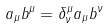<formula> <loc_0><loc_0><loc_500><loc_500>a _ { \mu } b ^ { \mu } = \delta ^ { \mu } _ { \nu } a _ { \mu } b ^ { \nu }</formula> 